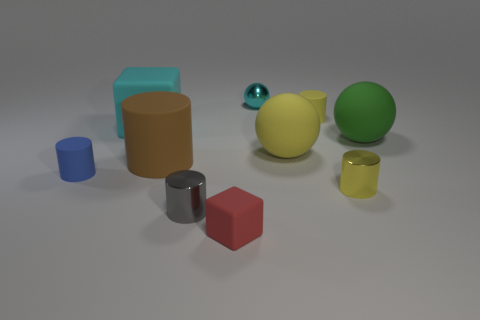How many metal things have the same color as the big rubber cube?
Provide a short and direct response. 1. There is a red cube that is made of the same material as the large yellow ball; what is its size?
Your answer should be compact. Small. How big is the matte sphere that is on the right side of the yellow object to the right of the tiny matte object to the right of the tiny red matte object?
Offer a very short reply. Large. What size is the yellow cylinder that is behind the large green rubber sphere?
Ensure brevity in your answer.  Small. How many blue things are metal cylinders or small matte cylinders?
Your answer should be very brief. 1. Are there any matte objects of the same size as the blue cylinder?
Ensure brevity in your answer.  Yes. What is the material of the brown thing that is the same size as the cyan matte object?
Your answer should be very brief. Rubber. There is a rubber block in front of the blue cylinder; is its size the same as the rubber cube behind the large green ball?
Your answer should be very brief. No. How many things are large cyan objects or tiny yellow things that are behind the small blue rubber cylinder?
Your response must be concise. 2. Is there another metal object of the same shape as the tiny red object?
Ensure brevity in your answer.  No. 